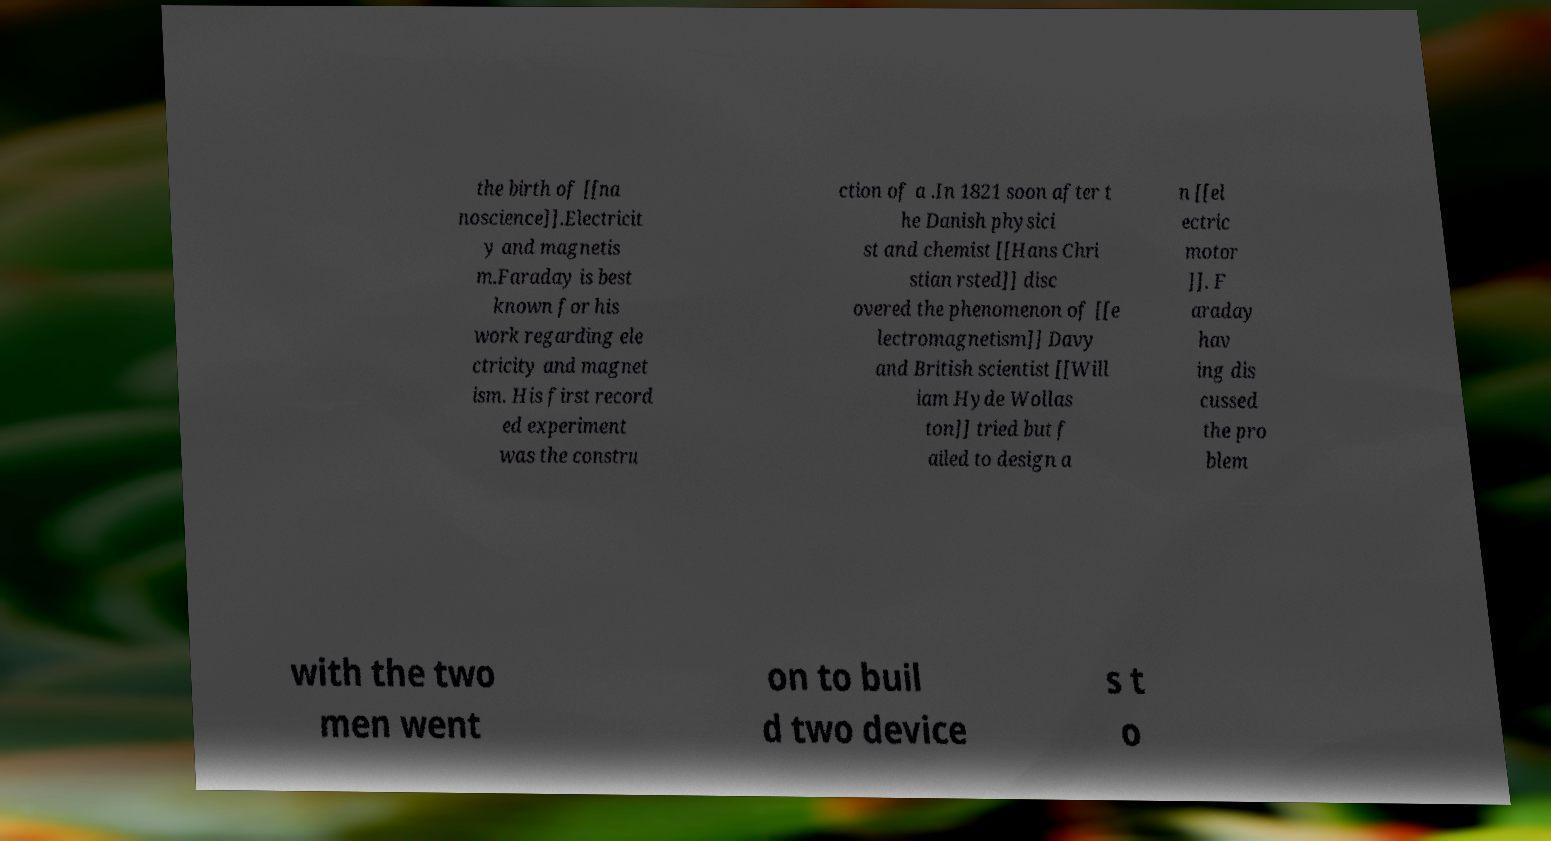Can you accurately transcribe the text from the provided image for me? the birth of [[na noscience]].Electricit y and magnetis m.Faraday is best known for his work regarding ele ctricity and magnet ism. His first record ed experiment was the constru ction of a .In 1821 soon after t he Danish physici st and chemist [[Hans Chri stian rsted]] disc overed the phenomenon of [[e lectromagnetism]] Davy and British scientist [[Will iam Hyde Wollas ton]] tried but f ailed to design a n [[el ectric motor ]]. F araday hav ing dis cussed the pro blem with the two men went on to buil d two device s t o 